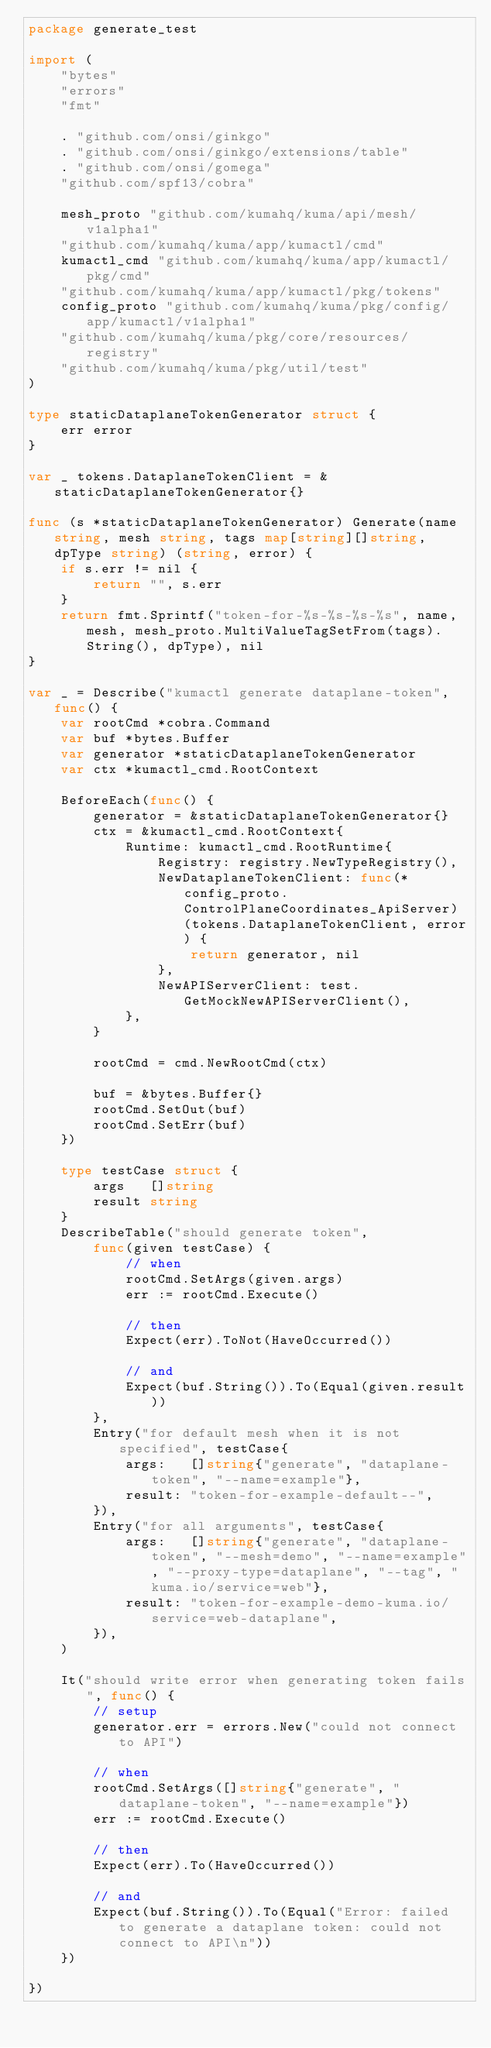<code> <loc_0><loc_0><loc_500><loc_500><_Go_>package generate_test

import (
	"bytes"
	"errors"
	"fmt"

	. "github.com/onsi/ginkgo"
	. "github.com/onsi/ginkgo/extensions/table"
	. "github.com/onsi/gomega"
	"github.com/spf13/cobra"

	mesh_proto "github.com/kumahq/kuma/api/mesh/v1alpha1"
	"github.com/kumahq/kuma/app/kumactl/cmd"
	kumactl_cmd "github.com/kumahq/kuma/app/kumactl/pkg/cmd"
	"github.com/kumahq/kuma/app/kumactl/pkg/tokens"
	config_proto "github.com/kumahq/kuma/pkg/config/app/kumactl/v1alpha1"
	"github.com/kumahq/kuma/pkg/core/resources/registry"
	"github.com/kumahq/kuma/pkg/util/test"
)

type staticDataplaneTokenGenerator struct {
	err error
}

var _ tokens.DataplaneTokenClient = &staticDataplaneTokenGenerator{}

func (s *staticDataplaneTokenGenerator) Generate(name string, mesh string, tags map[string][]string, dpType string) (string, error) {
	if s.err != nil {
		return "", s.err
	}
	return fmt.Sprintf("token-for-%s-%s-%s-%s", name, mesh, mesh_proto.MultiValueTagSetFrom(tags).String(), dpType), nil
}

var _ = Describe("kumactl generate dataplane-token", func() {
	var rootCmd *cobra.Command
	var buf *bytes.Buffer
	var generator *staticDataplaneTokenGenerator
	var ctx *kumactl_cmd.RootContext

	BeforeEach(func() {
		generator = &staticDataplaneTokenGenerator{}
		ctx = &kumactl_cmd.RootContext{
			Runtime: kumactl_cmd.RootRuntime{
				Registry: registry.NewTypeRegistry(),
				NewDataplaneTokenClient: func(*config_proto.ControlPlaneCoordinates_ApiServer) (tokens.DataplaneTokenClient, error) {
					return generator, nil
				},
				NewAPIServerClient: test.GetMockNewAPIServerClient(),
			},
		}

		rootCmd = cmd.NewRootCmd(ctx)

		buf = &bytes.Buffer{}
		rootCmd.SetOut(buf)
		rootCmd.SetErr(buf)
	})

	type testCase struct {
		args   []string
		result string
	}
	DescribeTable("should generate token",
		func(given testCase) {
			// when
			rootCmd.SetArgs(given.args)
			err := rootCmd.Execute()

			// then
			Expect(err).ToNot(HaveOccurred())

			// and
			Expect(buf.String()).To(Equal(given.result))
		},
		Entry("for default mesh when it is not specified", testCase{
			args:   []string{"generate", "dataplane-token", "--name=example"},
			result: "token-for-example-default--",
		}),
		Entry("for all arguments", testCase{
			args:   []string{"generate", "dataplane-token", "--mesh=demo", "--name=example", "--proxy-type=dataplane", "--tag", "kuma.io/service=web"},
			result: "token-for-example-demo-kuma.io/service=web-dataplane",
		}),
	)

	It("should write error when generating token fails", func() {
		// setup
		generator.err = errors.New("could not connect to API")

		// when
		rootCmd.SetArgs([]string{"generate", "dataplane-token", "--name=example"})
		err := rootCmd.Execute()

		// then
		Expect(err).To(HaveOccurred())

		// and
		Expect(buf.String()).To(Equal("Error: failed to generate a dataplane token: could not connect to API\n"))
	})

})
</code> 